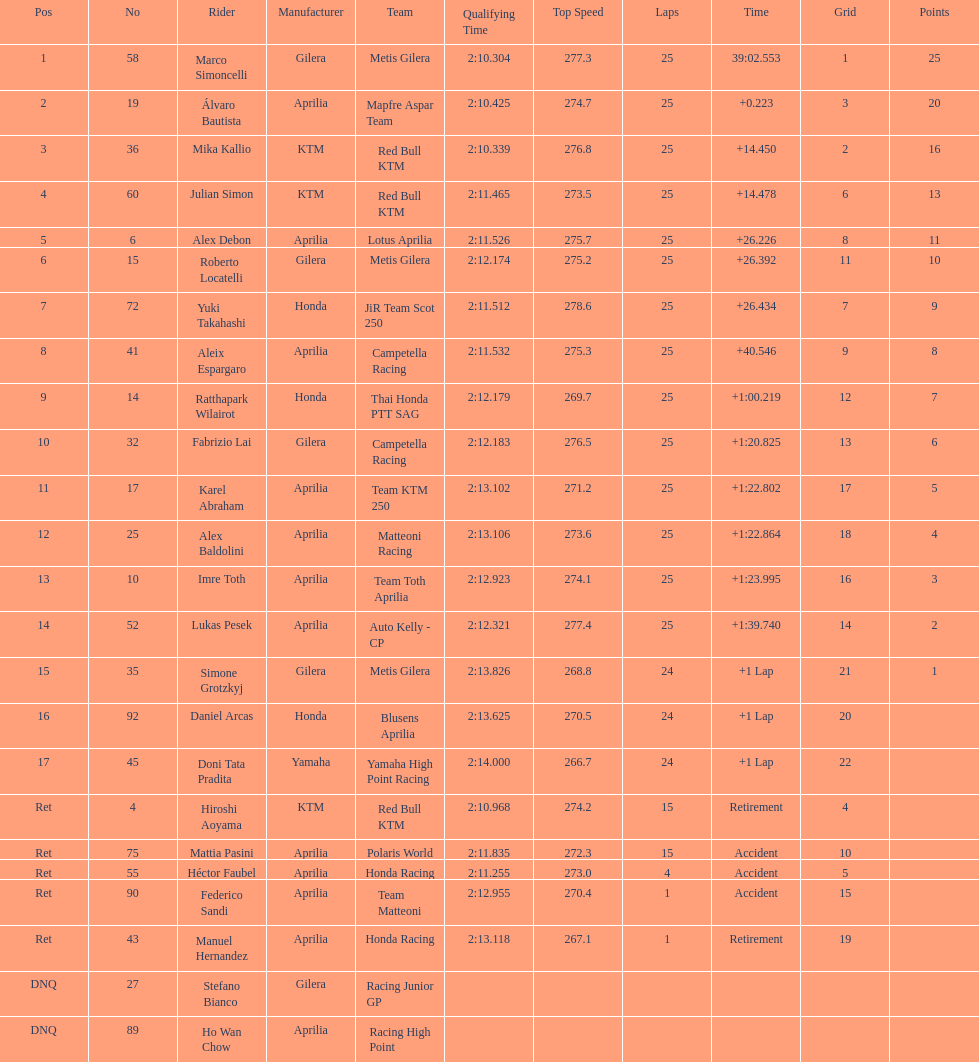Who is marco simoncelli's manufacturer Gilera. I'm looking to parse the entire table for insights. Could you assist me with that? {'header': ['Pos', 'No', 'Rider', 'Manufacturer', 'Team', 'Qualifying Time', 'Top Speed', 'Laps', 'Time', 'Grid', 'Points'], 'rows': [['1', '58', 'Marco Simoncelli', 'Gilera', 'Metis Gilera', '2:10.304', '277.3', '25', '39:02.553', '1', '25'], ['2', '19', 'Álvaro Bautista', 'Aprilia', 'Mapfre Aspar Team', '2:10.425', '274.7', '25', '+0.223', '3', '20'], ['3', '36', 'Mika Kallio', 'KTM', 'Red Bull KTM', '2:10.339', '276.8', '25', '+14.450', '2', '16'], ['4', '60', 'Julian Simon', 'KTM', 'Red Bull KTM', '2:11.465', '273.5', '25', '+14.478', '6', '13'], ['5', '6', 'Alex Debon', 'Aprilia', 'Lotus Aprilia', '2:11.526', '275.7', '25', '+26.226', '8', '11'], ['6', '15', 'Roberto Locatelli', 'Gilera', 'Metis Gilera', '2:12.174', '275.2', '25', '+26.392', '11', '10'], ['7', '72', 'Yuki Takahashi', 'Honda', 'JiR Team Scot 250', '2:11.512', '278.6', '25', '+26.434', '7', '9'], ['8', '41', 'Aleix Espargaro', 'Aprilia', 'Campetella Racing', '2:11.532', '275.3', '25', '+40.546', '9', '8'], ['9', '14', 'Ratthapark Wilairot', 'Honda', 'Thai Honda PTT SAG', '2:12.179', '269.7', '25', '+1:00.219', '12', '7'], ['10', '32', 'Fabrizio Lai', 'Gilera', 'Campetella Racing', '2:12.183', '276.5', '25', '+1:20.825', '13', '6'], ['11', '17', 'Karel Abraham', 'Aprilia', 'Team KTM 250', '2:13.102', '271.2', '25', '+1:22.802', '17', '5'], ['12', '25', 'Alex Baldolini', 'Aprilia', 'Matteoni Racing', '2:13.106', '273.6', '25', '+1:22.864', '18', '4'], ['13', '10', 'Imre Toth', 'Aprilia', 'Team Toth Aprilia', '2:12.923', '274.1', '25', '+1:23.995', '16', '3'], ['14', '52', 'Lukas Pesek', 'Aprilia', 'Auto Kelly - CP', '2:12.321', '277.4', '25', '+1:39.740', '14', '2'], ['15', '35', 'Simone Grotzkyj', 'Gilera', 'Metis Gilera', '2:13.826', '268.8', '24', '+1 Lap', '21', '1'], ['16', '92', 'Daniel Arcas', 'Honda', 'Blusens Aprilia', '2:13.625', '270.5', '24', '+1 Lap', '20', ''], ['17', '45', 'Doni Tata Pradita', 'Yamaha', 'Yamaha High Point Racing', '2:14.000', '266.7', '24', '+1 Lap', '22', ''], ['Ret', '4', 'Hiroshi Aoyama', 'KTM', 'Red Bull KTM', '2:10.968', '274.2', '15', 'Retirement', '4', ''], ['Ret', '75', 'Mattia Pasini', 'Aprilia', 'Polaris World', '2:11.835', '272.3', '15', 'Accident', '10', ''], ['Ret', '55', 'Héctor Faubel', 'Aprilia', 'Honda Racing', '2:11.255', '273.0', '4', 'Accident', '5', ''], ['Ret', '90', 'Federico Sandi', 'Aprilia', 'Team Matteoni', '2:12.955', '270.4', '1', 'Accident', '15', ''], ['Ret', '43', 'Manuel Hernandez', 'Aprilia', 'Honda Racing', '2:13.118', '267.1', '1', 'Retirement', '19', ''], ['DNQ', '27', 'Stefano Bianco', 'Gilera', 'Racing Junior GP', '', '', '', '', '', ''], ['DNQ', '89', 'Ho Wan Chow', 'Aprilia', 'Racing High Point', '', '', '', '', '', '']]} 